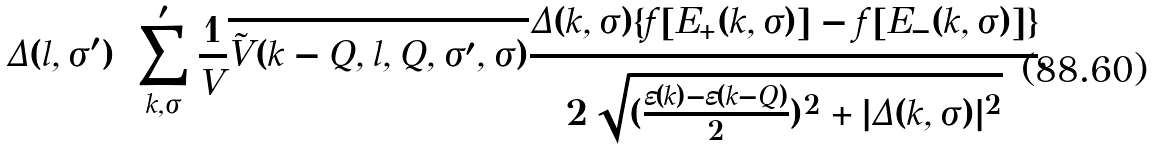Convert formula to latex. <formula><loc_0><loc_0><loc_500><loc_500>\Delta ( { l , \sigma ^ { \prime } } ) = \sum _ { k , \sigma } ^ { \prime } \frac { 1 } { V } \overline { \tilde { V } ( { k - Q , l , Q , \sigma ^ { \prime } , \sigma } ) } \frac { \Delta ( { k , \sigma } ) \{ f [ E _ { + } ( { k , \sigma } ) ] - f [ E _ { - } ( { k , \sigma } ) ] \} } { 2 \sqrt { ( \frac { \varepsilon ( { k } ) - \varepsilon ( { k - Q } ) } { 2 } ) ^ { 2 } + | \Delta ( { k , \sigma } ) | ^ { 2 } } } ,</formula> 